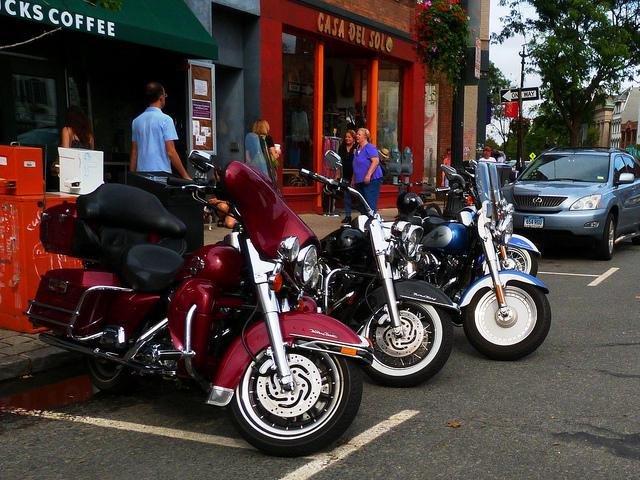What is the parent organization of the SUV? Please explain your reasoning. toyota. Toyota owns the suv. 